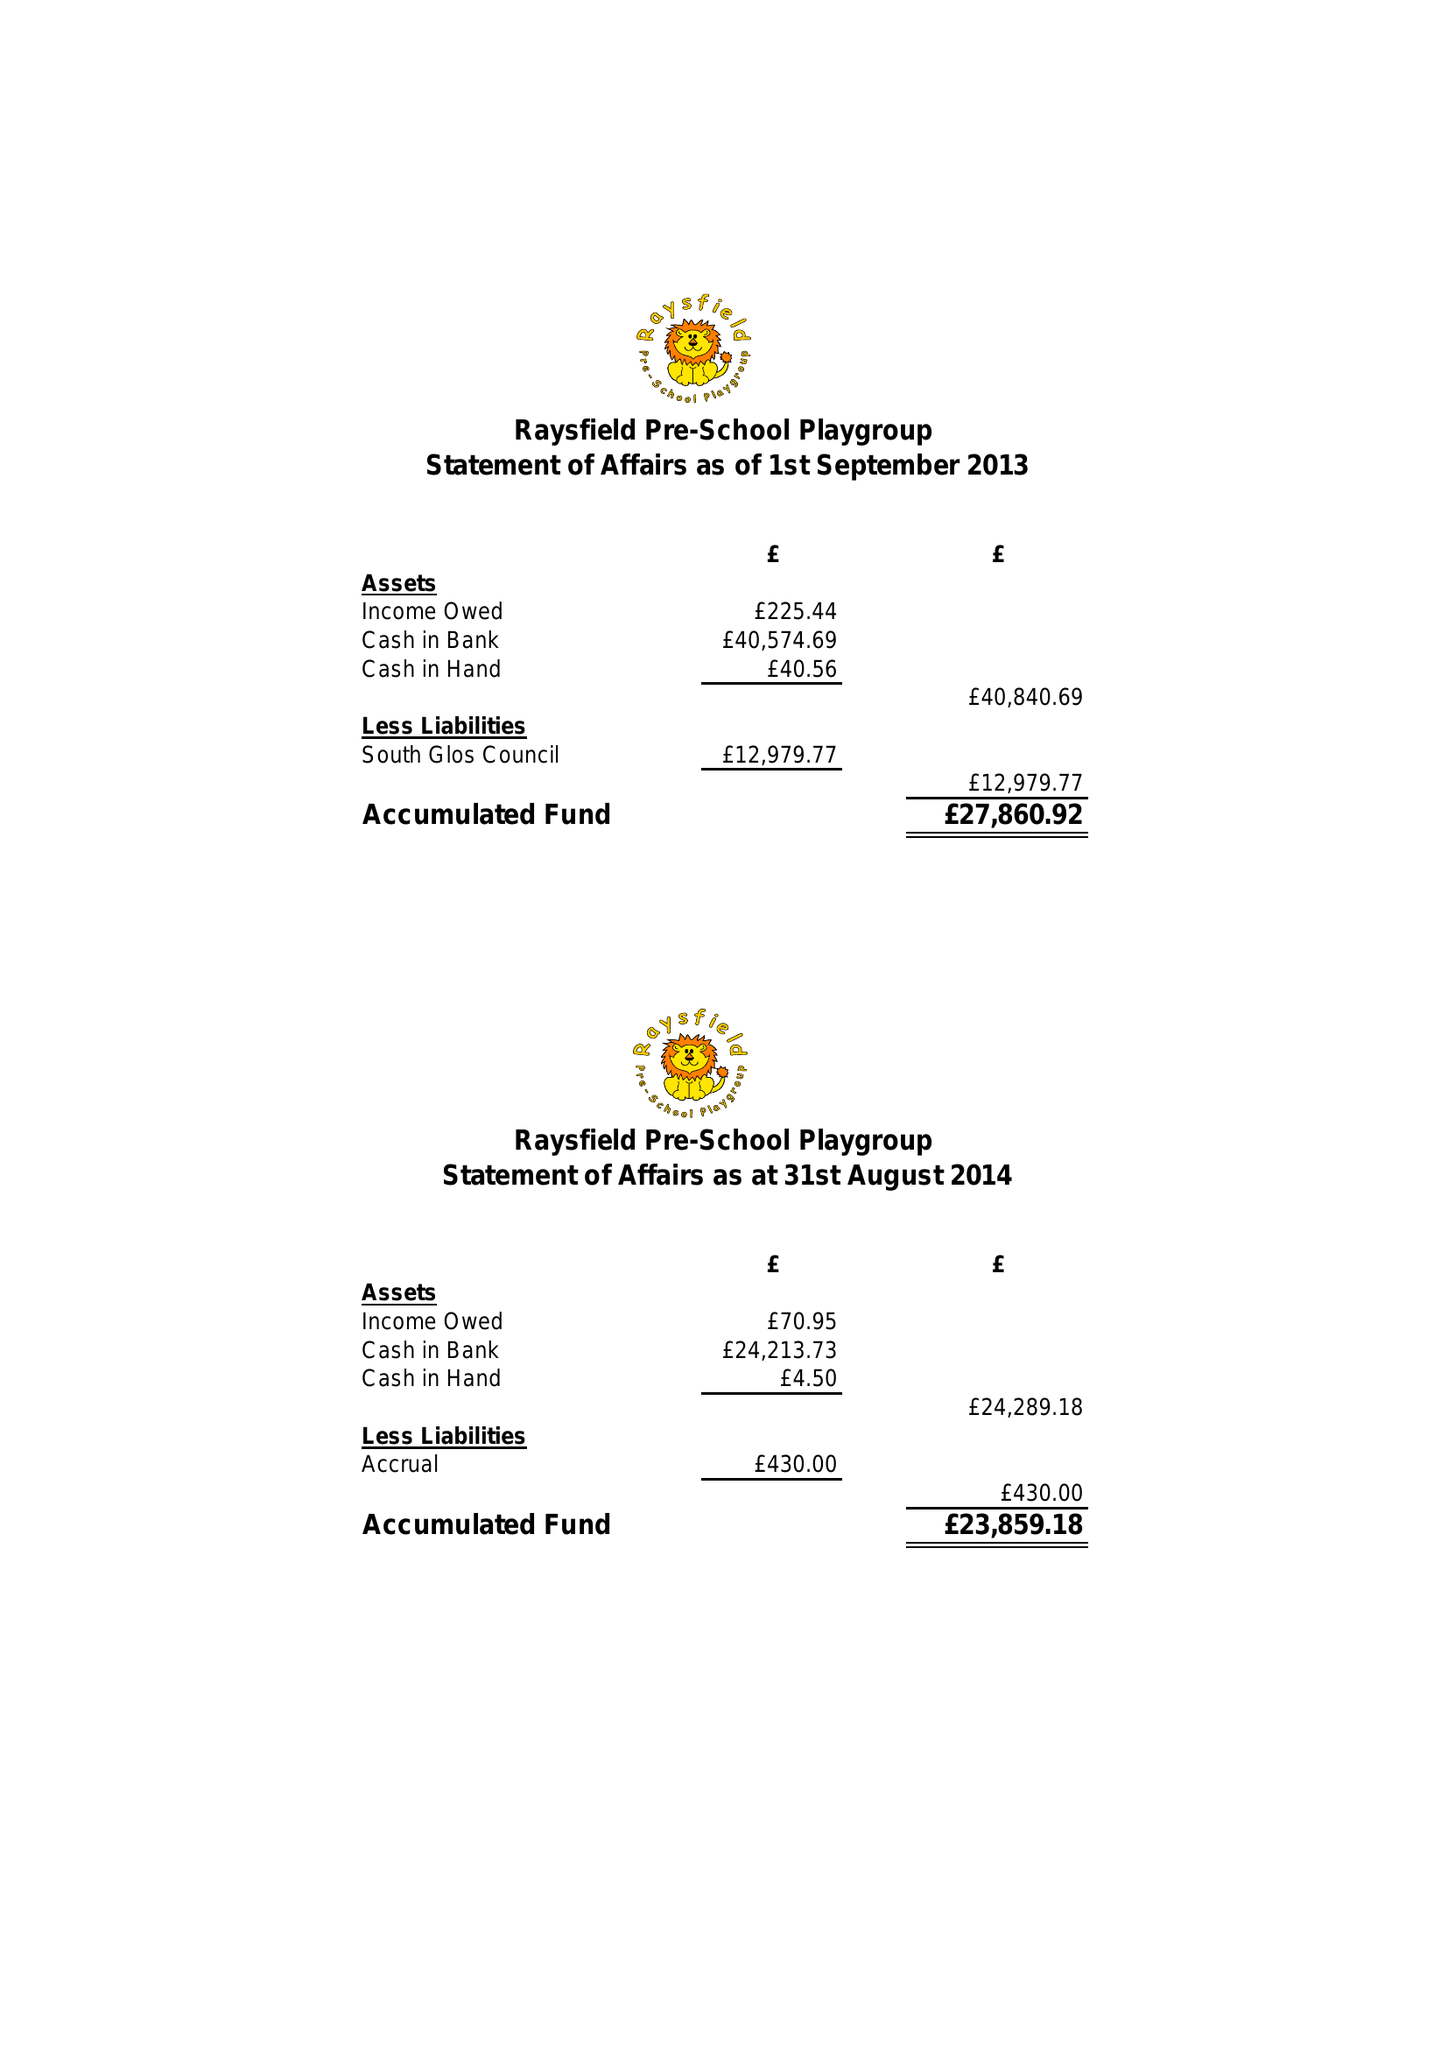What is the value for the address__post_town?
Answer the question using a single word or phrase. BRISTOL 